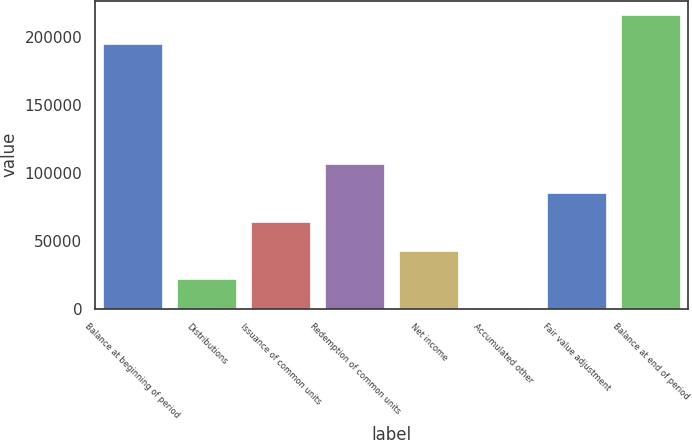Convert chart. <chart><loc_0><loc_0><loc_500><loc_500><bar_chart><fcel>Balance at beginning of period<fcel>Distributions<fcel>Issuance of common units<fcel>Redemption of common units<fcel>Net income<fcel>Accumulated other<fcel>Fair value adjustment<fcel>Balance at end of period<nl><fcel>195030<fcel>21639.9<fcel>64143.7<fcel>106648<fcel>42891.8<fcel>388<fcel>85395.6<fcel>216282<nl></chart> 